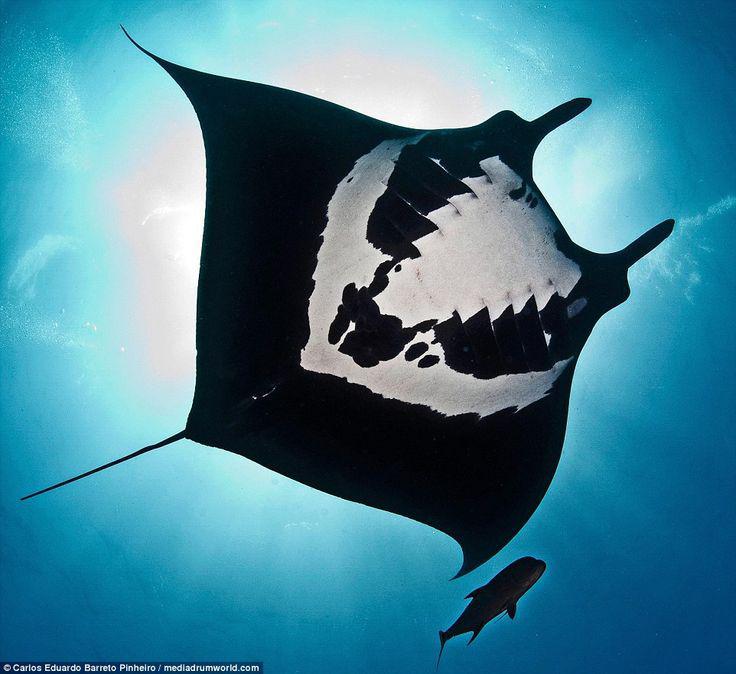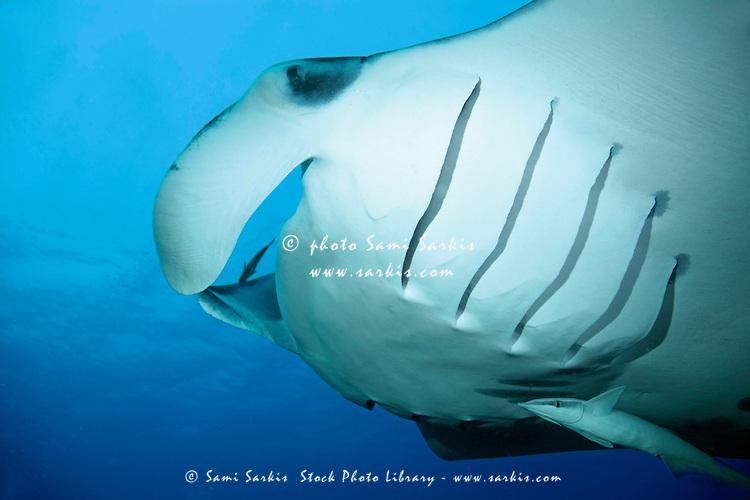The first image is the image on the left, the second image is the image on the right. Examine the images to the left and right. Is the description "The stingray on the left is black." accurate? Answer yes or no. Yes. 